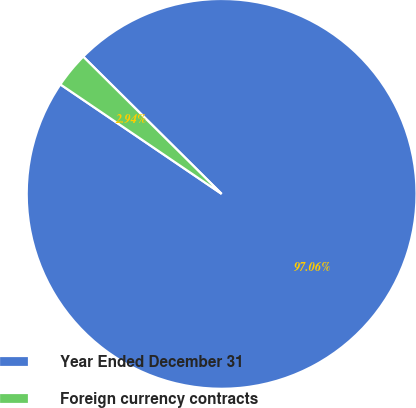Convert chart to OTSL. <chart><loc_0><loc_0><loc_500><loc_500><pie_chart><fcel>Year Ended December 31<fcel>Foreign currency contracts<nl><fcel>97.06%<fcel>2.94%<nl></chart> 